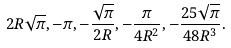<formula> <loc_0><loc_0><loc_500><loc_500>2 R \sqrt { \pi } , - \pi , - \frac { \sqrt { \pi } } { 2 R } , - \frac { \pi } { 4 R ^ { 2 } } , - \frac { 2 5 \sqrt { \pi } } { 4 8 R ^ { 3 } } .</formula> 